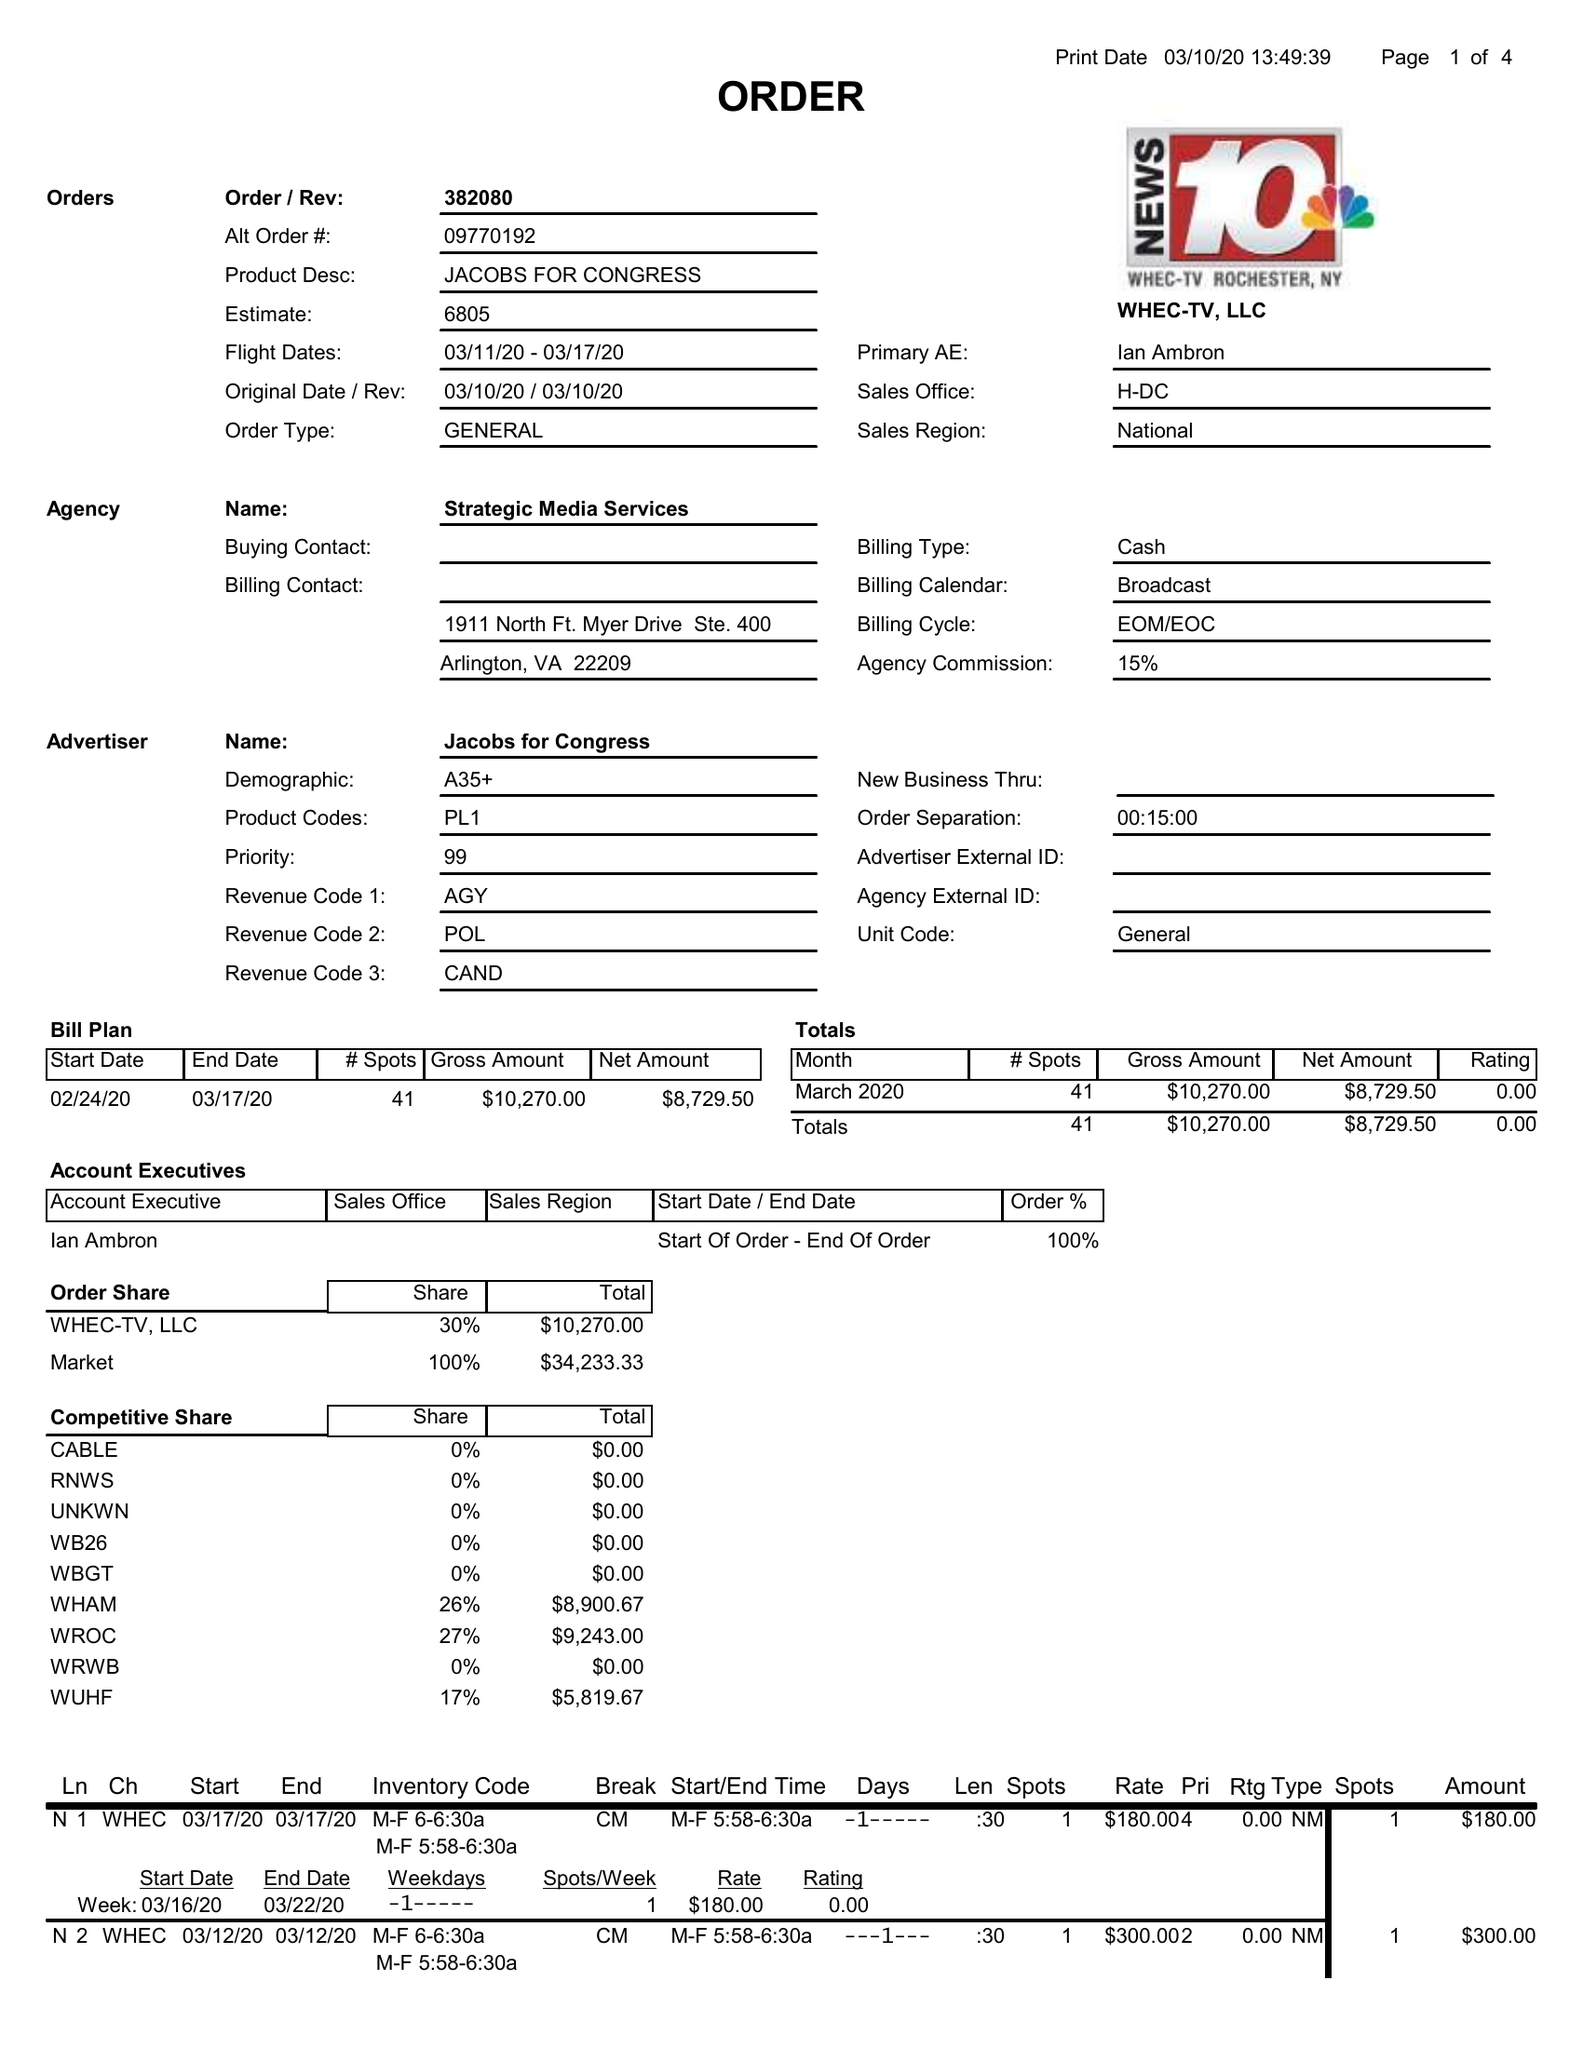What is the value for the flight_from?
Answer the question using a single word or phrase. 03/11/20 